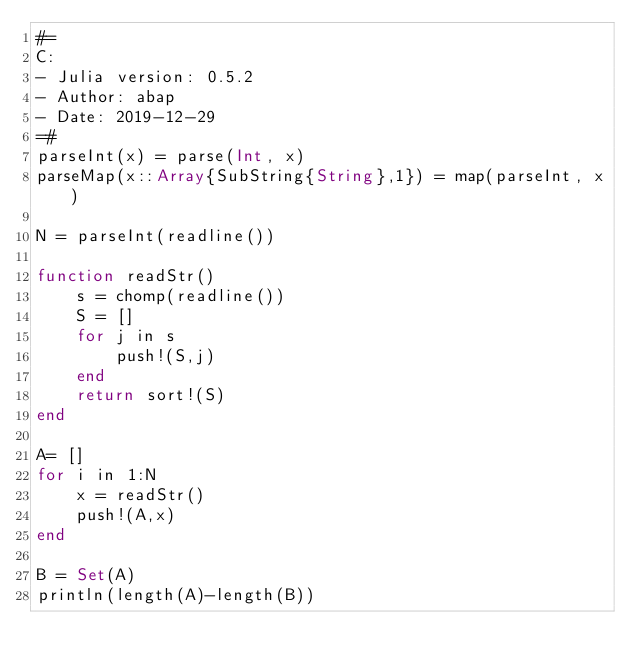Convert code to text. <code><loc_0><loc_0><loc_500><loc_500><_Julia_>#=
C:
- Julia version: 0.5.2
- Author: abap
- Date: 2019-12-29
=#
parseInt(x) = parse(Int, x)
parseMap(x::Array{SubString{String},1}) = map(parseInt, x)

N = parseInt(readline())

function readStr()
	s = chomp(readline())
	S = []
	for j in s
		push!(S,j)
	end
	return sort!(S)
end

A= []
for i in 1:N
	x = readStr()
	push!(A,x)
end

B = Set(A)
println(length(A)-length(B))</code> 